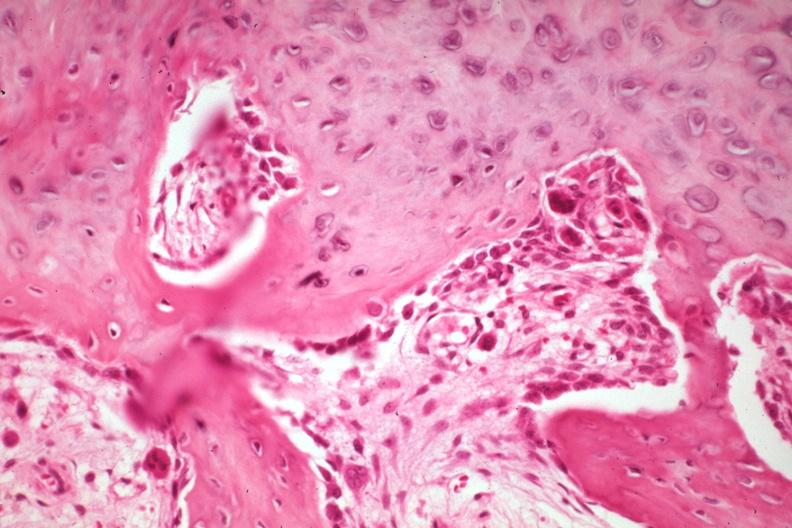what is present?
Answer the question using a single word or phrase. Joints 